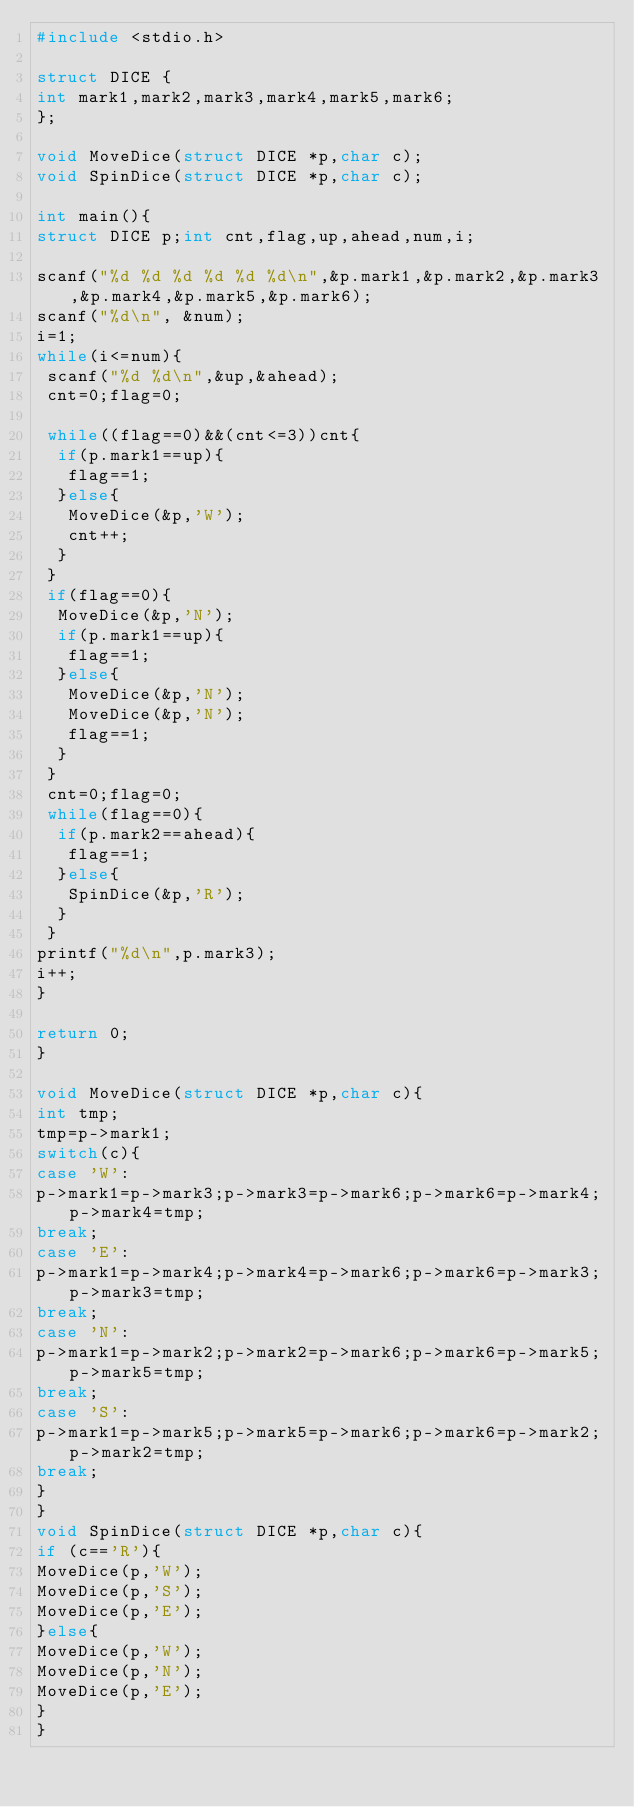Convert code to text. <code><loc_0><loc_0><loc_500><loc_500><_C_>#include <stdio.h>

struct DICE {
int mark1,mark2,mark3,mark4,mark5,mark6;
};

void MoveDice(struct DICE *p,char c);
void SpinDice(struct DICE *p,char c);

int main(){
struct DICE p;int cnt,flag,up,ahead,num,i;

scanf("%d %d %d %d %d %d\n",&p.mark1,&p.mark2,&p.mark3,&p.mark4,&p.mark5,&p.mark6);
scanf("%d\n", &num);
i=1;
while(i<=num){
 scanf("%d %d\n",&up,&ahead);
 cnt=0;flag=0;

 while((flag==0)&&(cnt<=3))cnt{
  if(p.mark1==up){
   flag==1;
  }else{
   MoveDice(&p,'W');
   cnt++;
  }
 }
 if(flag==0){
  MoveDice(&p,'N'); 
  if(p.mark1==up){
   flag==1;
  }else{
   MoveDice(&p,'N'); 
   MoveDice(&p,'N'); 
   flag==1; 
  }
 }
 cnt=0;flag=0;
 while(flag==0){
  if(p.mark2==ahead){
   flag==1;
  }else{
   SpinDice(&p,'R');
  }
 }
printf("%d\n",p.mark3);
i++;
}

return 0;
}

void MoveDice(struct DICE *p,char c){
int tmp;
tmp=p->mark1;
switch(c){
case 'W':
p->mark1=p->mark3;p->mark3=p->mark6;p->mark6=p->mark4;p->mark4=tmp;
break;
case 'E':
p->mark1=p->mark4;p->mark4=p->mark6;p->mark6=p->mark3;p->mark3=tmp;
break;
case 'N':
p->mark1=p->mark2;p->mark2=p->mark6;p->mark6=p->mark5;p->mark5=tmp;
break;
case 'S':
p->mark1=p->mark5;p->mark5=p->mark6;p->mark6=p->mark2;p->mark2=tmp;
break;
}
}
void SpinDice(struct DICE *p,char c){
if (c=='R'){
MoveDice(p,'W');
MoveDice(p,'S');
MoveDice(p,'E');
}else{
MoveDice(p,'W');
MoveDice(p,'N');
MoveDice(p,'E');
}
}</code> 